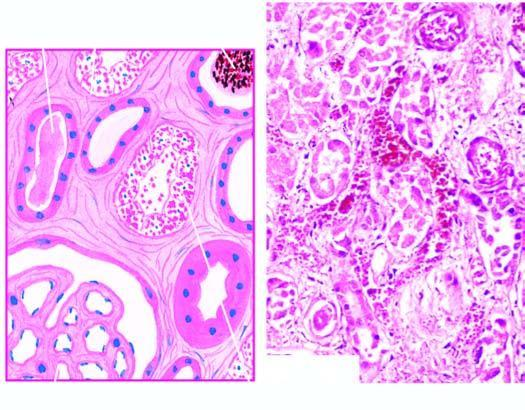s there focal necrosis along the nephron involving proximal convoluted tubule as well as distal convoluted tubule dct?
Answer the question using a single word or phrase. Yes 